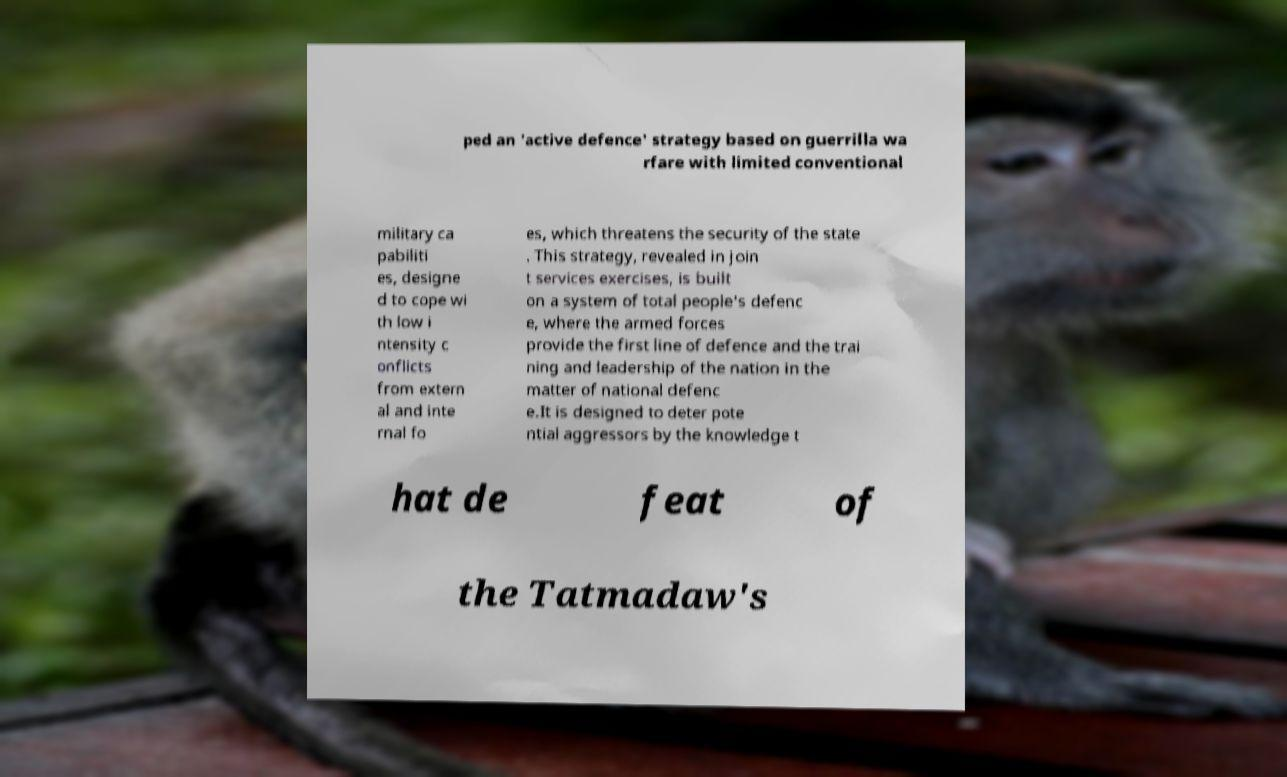I need the written content from this picture converted into text. Can you do that? ped an 'active defence' strategy based on guerrilla wa rfare with limited conventional military ca pabiliti es, designe d to cope wi th low i ntensity c onflicts from extern al and inte rnal fo es, which threatens the security of the state . This strategy, revealed in join t services exercises, is built on a system of total people's defenc e, where the armed forces provide the first line of defence and the trai ning and leadership of the nation in the matter of national defenc e.It is designed to deter pote ntial aggressors by the knowledge t hat de feat of the Tatmadaw's 